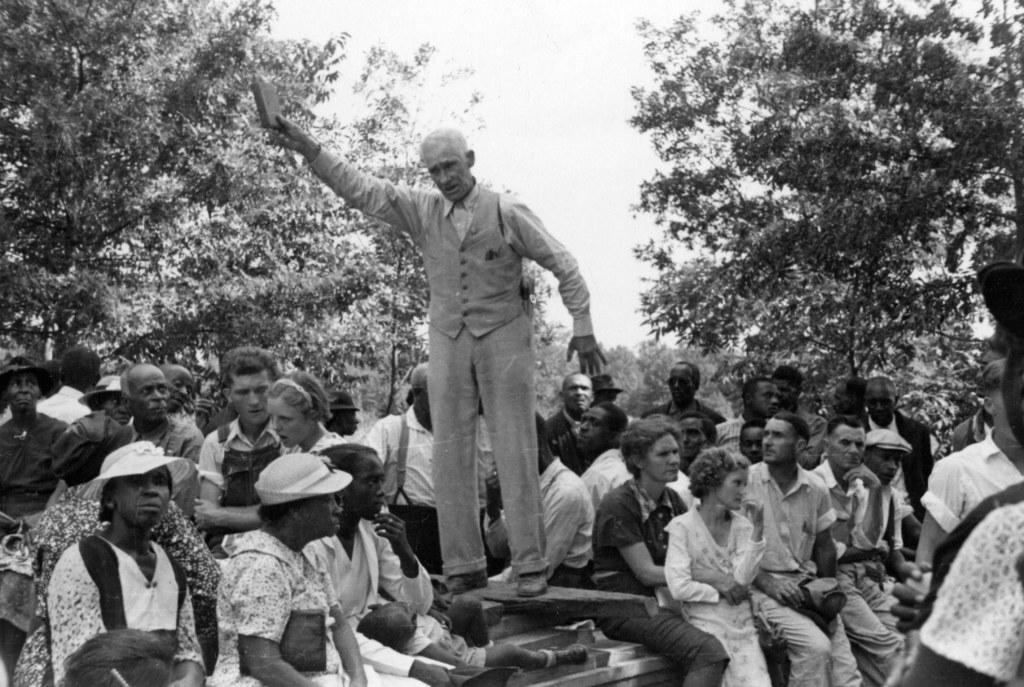Please provide a concise description of this image. In this image a man is standing holding a book. Around him there are many people. In the background there are trees. 